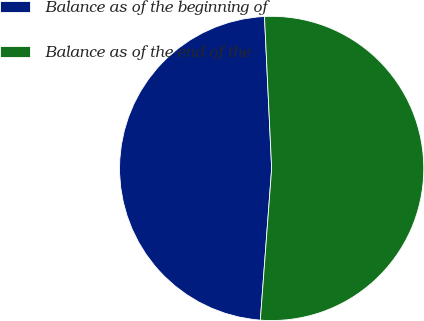<chart> <loc_0><loc_0><loc_500><loc_500><pie_chart><fcel>Balance as of the beginning of<fcel>Balance as of the end of the<nl><fcel>48.06%<fcel>51.94%<nl></chart> 